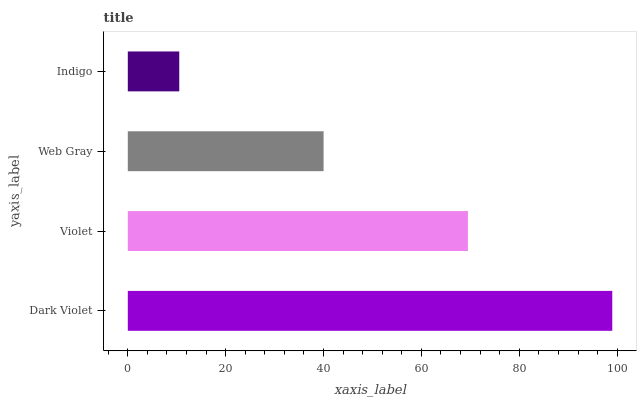Is Indigo the minimum?
Answer yes or no. Yes. Is Dark Violet the maximum?
Answer yes or no. Yes. Is Violet the minimum?
Answer yes or no. No. Is Violet the maximum?
Answer yes or no. No. Is Dark Violet greater than Violet?
Answer yes or no. Yes. Is Violet less than Dark Violet?
Answer yes or no. Yes. Is Violet greater than Dark Violet?
Answer yes or no. No. Is Dark Violet less than Violet?
Answer yes or no. No. Is Violet the high median?
Answer yes or no. Yes. Is Web Gray the low median?
Answer yes or no. Yes. Is Web Gray the high median?
Answer yes or no. No. Is Dark Violet the low median?
Answer yes or no. No. 